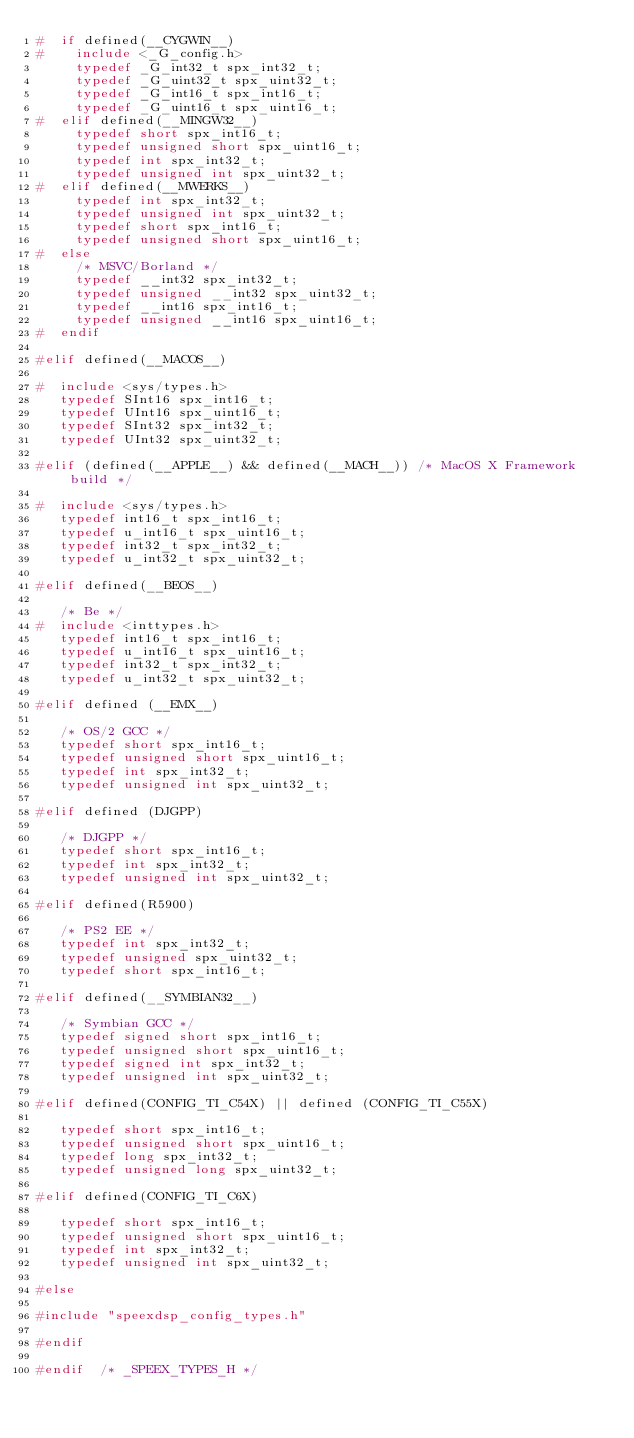<code> <loc_0><loc_0><loc_500><loc_500><_C_>#  if defined(__CYGWIN__)
#    include <_G_config.h>
     typedef _G_int32_t spx_int32_t;
     typedef _G_uint32_t spx_uint32_t;
     typedef _G_int16_t spx_int16_t;
     typedef _G_uint16_t spx_uint16_t;
#  elif defined(__MINGW32__)
     typedef short spx_int16_t;
     typedef unsigned short spx_uint16_t;
     typedef int spx_int32_t;
     typedef unsigned int spx_uint32_t;
#  elif defined(__MWERKS__)
     typedef int spx_int32_t;
     typedef unsigned int spx_uint32_t;
     typedef short spx_int16_t;
     typedef unsigned short spx_uint16_t;
#  else
     /* MSVC/Borland */
     typedef __int32 spx_int32_t;
     typedef unsigned __int32 spx_uint32_t;
     typedef __int16 spx_int16_t;
     typedef unsigned __int16 spx_uint16_t;
#  endif

#elif defined(__MACOS__)

#  include <sys/types.h>
   typedef SInt16 spx_int16_t;
   typedef UInt16 spx_uint16_t;
   typedef SInt32 spx_int32_t;
   typedef UInt32 spx_uint32_t;

#elif (defined(__APPLE__) && defined(__MACH__)) /* MacOS X Framework build */

#  include <sys/types.h>
   typedef int16_t spx_int16_t;
   typedef u_int16_t spx_uint16_t;
   typedef int32_t spx_int32_t;
   typedef u_int32_t spx_uint32_t;

#elif defined(__BEOS__)

   /* Be */
#  include <inttypes.h>
   typedef int16_t spx_int16_t;
   typedef u_int16_t spx_uint16_t;
   typedef int32_t spx_int32_t;
   typedef u_int32_t spx_uint32_t;

#elif defined (__EMX__)

   /* OS/2 GCC */
   typedef short spx_int16_t;
   typedef unsigned short spx_uint16_t;
   typedef int spx_int32_t;
   typedef unsigned int spx_uint32_t;

#elif defined (DJGPP)

   /* DJGPP */
   typedef short spx_int16_t;
   typedef int spx_int32_t;
   typedef unsigned int spx_uint32_t;

#elif defined(R5900)

   /* PS2 EE */
   typedef int spx_int32_t;
   typedef unsigned spx_uint32_t;
   typedef short spx_int16_t;

#elif defined(__SYMBIAN32__)

   /* Symbian GCC */
   typedef signed short spx_int16_t;
   typedef unsigned short spx_uint16_t;
   typedef signed int spx_int32_t;
   typedef unsigned int spx_uint32_t;

#elif defined(CONFIG_TI_C54X) || defined (CONFIG_TI_C55X)

   typedef short spx_int16_t;
   typedef unsigned short spx_uint16_t;
   typedef long spx_int32_t;
   typedef unsigned long spx_uint32_t;

#elif defined(CONFIG_TI_C6X)

   typedef short spx_int16_t;
   typedef unsigned short spx_uint16_t;
   typedef int spx_int32_t;
   typedef unsigned int spx_uint32_t;

#else

#include "speexdsp_config_types.h"

#endif

#endif  /* _SPEEX_TYPES_H */
</code> 